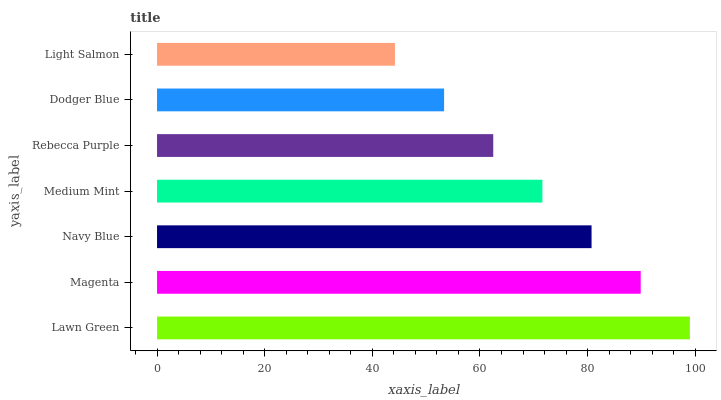Is Light Salmon the minimum?
Answer yes or no. Yes. Is Lawn Green the maximum?
Answer yes or no. Yes. Is Magenta the minimum?
Answer yes or no. No. Is Magenta the maximum?
Answer yes or no. No. Is Lawn Green greater than Magenta?
Answer yes or no. Yes. Is Magenta less than Lawn Green?
Answer yes or no. Yes. Is Magenta greater than Lawn Green?
Answer yes or no. No. Is Lawn Green less than Magenta?
Answer yes or no. No. Is Medium Mint the high median?
Answer yes or no. Yes. Is Medium Mint the low median?
Answer yes or no. Yes. Is Light Salmon the high median?
Answer yes or no. No. Is Light Salmon the low median?
Answer yes or no. No. 